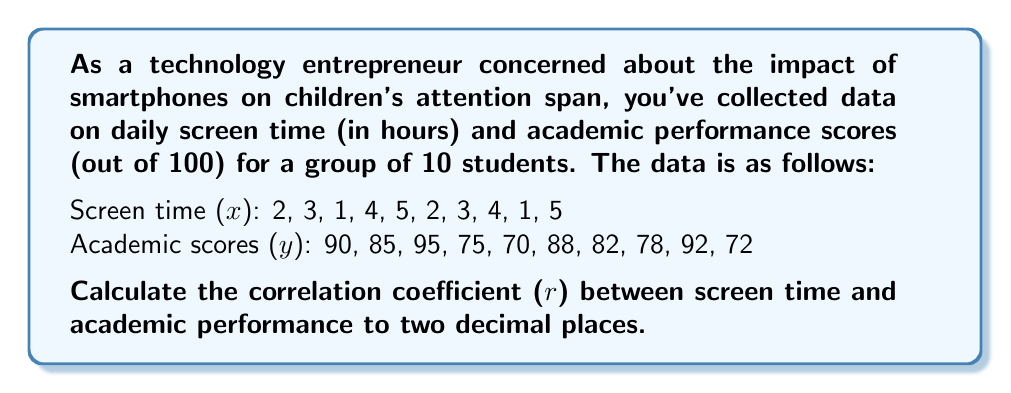Provide a solution to this math problem. To calculate the correlation coefficient (r), we'll use the formula:

$$ r = \frac{n\sum xy - \sum x \sum y}{\sqrt{[n\sum x^2 - (\sum x)^2][n\sum y^2 - (\sum y)^2]}} $$

Step 1: Calculate the sums and squared sums:
$\sum x = 30$
$\sum y = 827$
$\sum x^2 = 110$
$\sum y^2 = 69,109$
$\sum xy = 2,421$

Step 2: Calculate $n\sum xy$:
$n\sum xy = 10 \times 2,421 = 24,210$

Step 3: Calculate $\sum x \sum y$:
$\sum x \sum y = 30 \times 827 = 24,810$

Step 4: Calculate the numerator:
$n\sum xy - \sum x \sum y = 24,210 - 24,810 = -600$

Step 5: Calculate $n\sum x^2$ and $(\sum x)^2$:
$n\sum x^2 = 10 \times 110 = 1,100$
$(\sum x)^2 = 30^2 = 900$

Step 6: Calculate $n\sum y^2$ and $(\sum y)^2$:
$n\sum y^2 = 10 \times 69,109 = 691,090$
$(\sum y)^2 = 827^2 = 683,929$

Step 7: Calculate the denominator:
$\sqrt{[n\sum x^2 - (\sum x)^2][n\sum y^2 - (\sum y)^2]}$
$= \sqrt{[1,100 - 900][691,090 - 683,929]}$
$= \sqrt{200 \times 7,161}$
$= \sqrt{1,432,200}$
$= 1,196.75$

Step 8: Calculate the correlation coefficient:
$r = \frac{-600}{1,196.75} = -0.5013$

Round to two decimal places: $r = -0.50$
Answer: $-0.50$ 